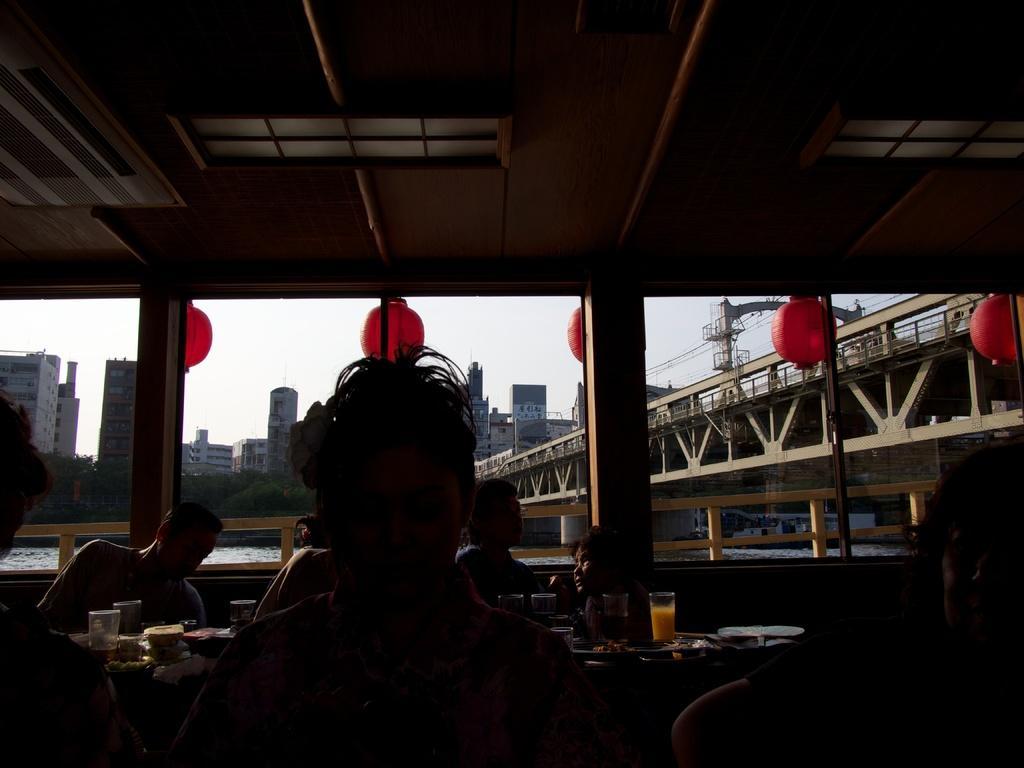How would you summarize this image in a sentence or two? In the image we can see there are many people sitting and wearing clothes. Here we can see there are tables and on the table, we can see the glass and liquid in the glass, and other things. Here we can see the bridge, water, trees and the buildings. We can even see decorative ball, electric wires and the sky. 